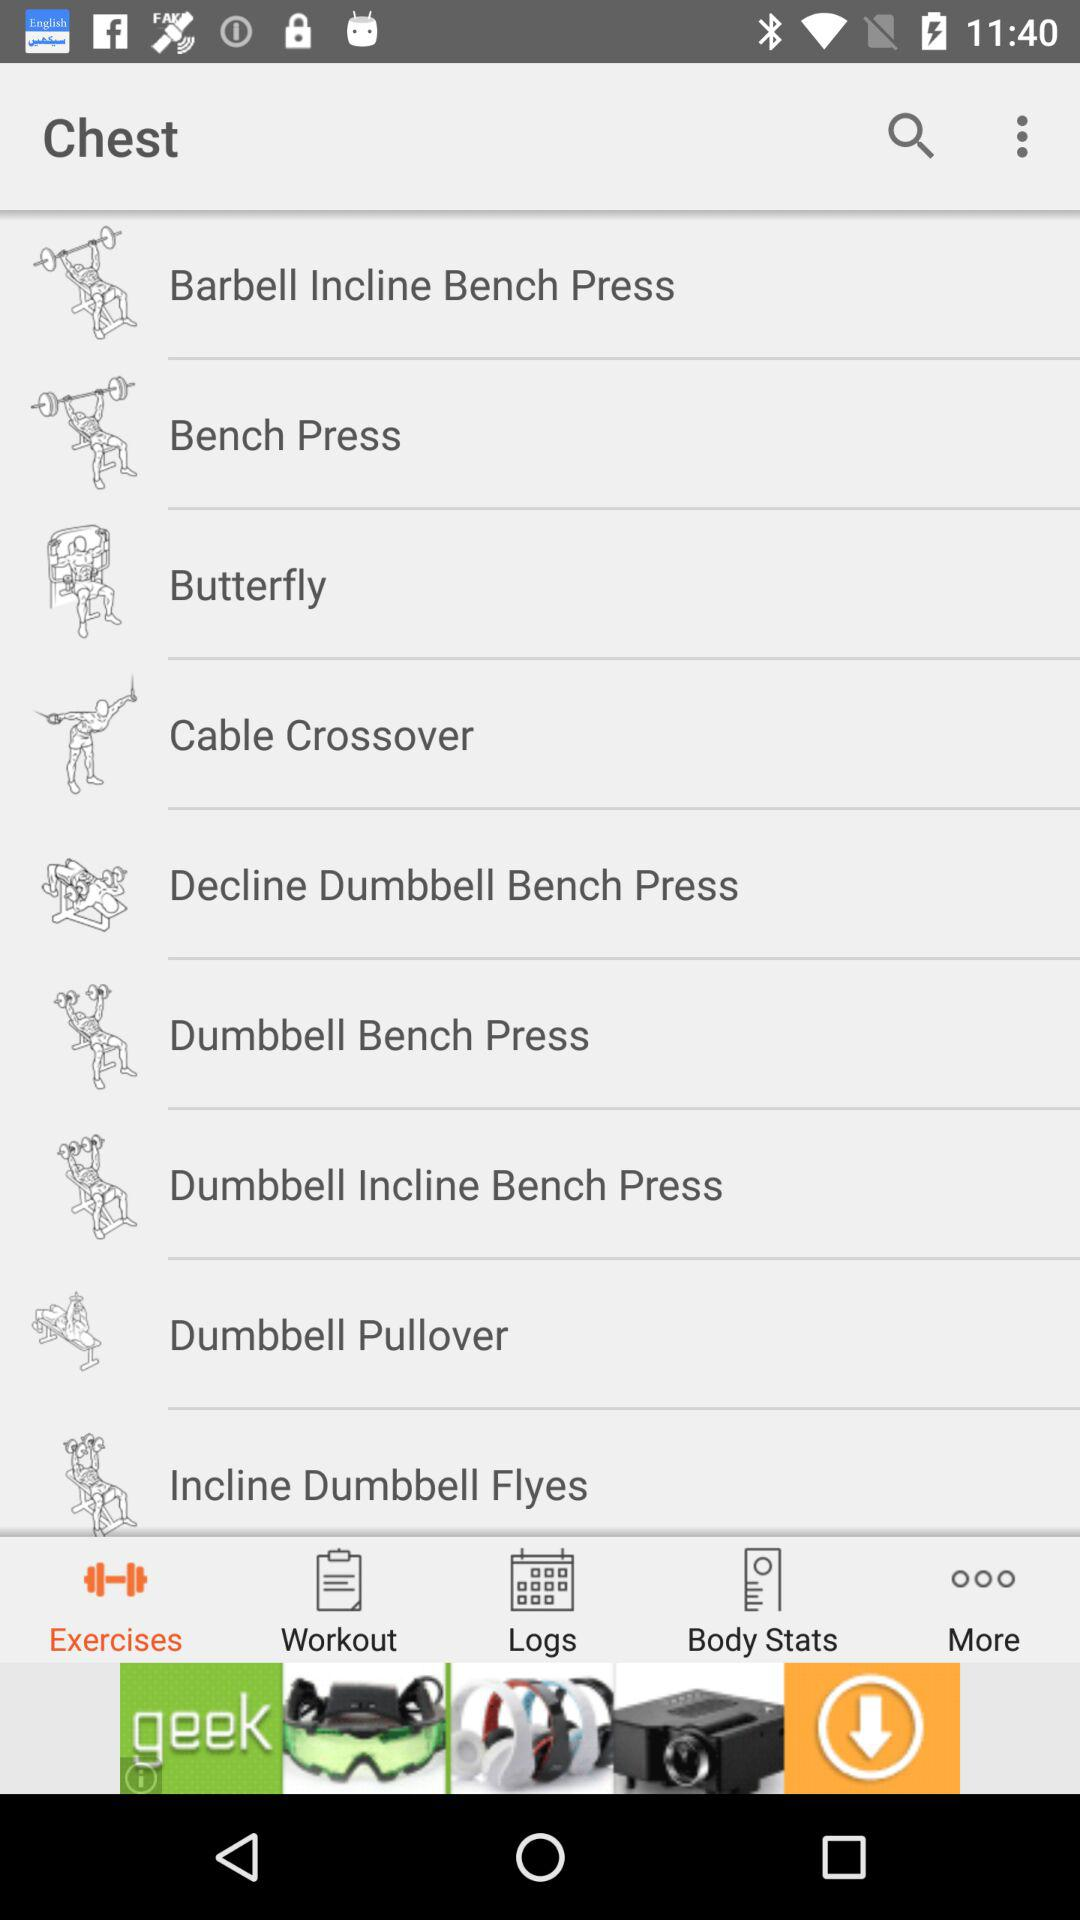Which tab is selected? The selected tab is "Exercises". 